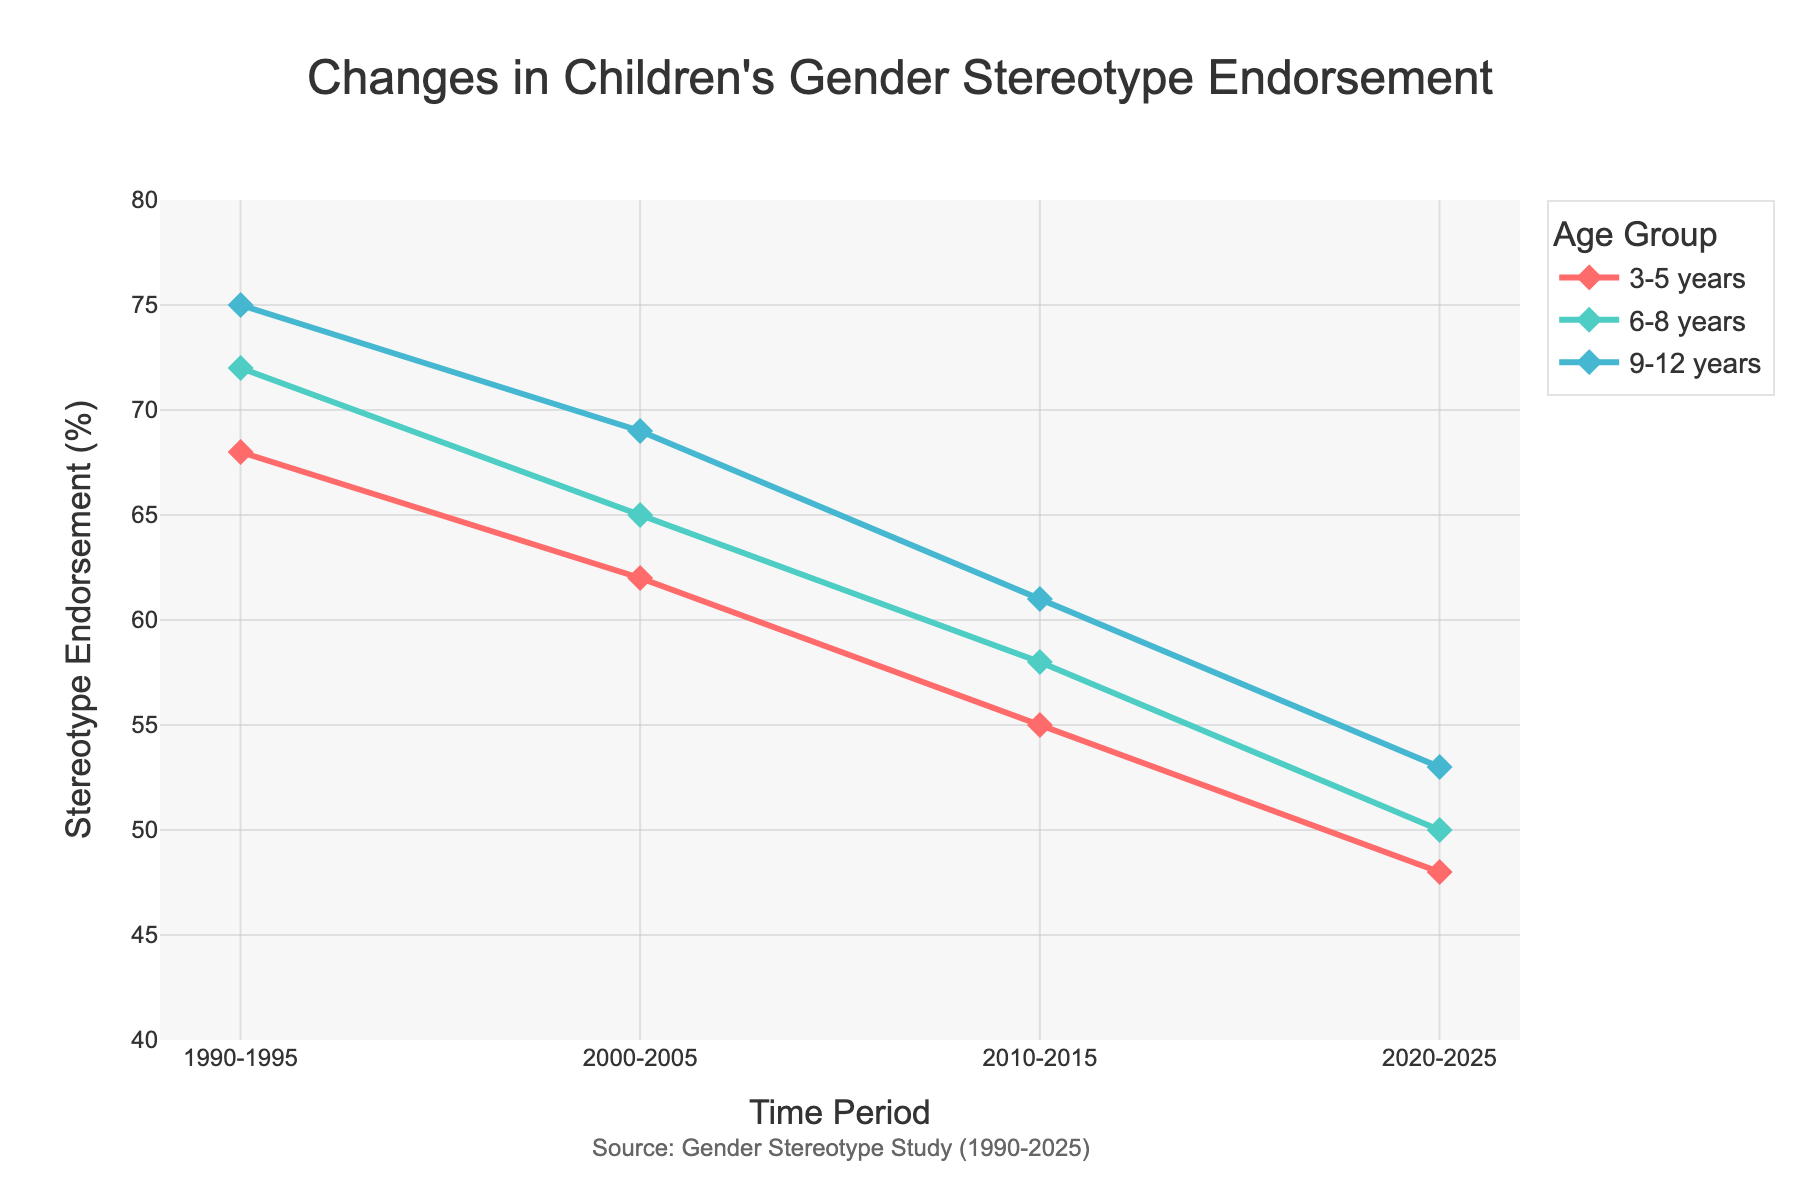What is the trend in gender stereotype endorsement for the 3-5 years age group over the past three decades? In the provided figure, the trend In the 3-5 years age group shows a steady decrease in gender stereotype endorsement over time. Initially starting at 68% in 1990-1995, it drops to 48% by 2020-2025.
Answer: Steady decrease Which age group showed the highest endorsement of gender stereotypes in the 2020-2025 period? The figure reveals that in the 2020-2025 period, the 9-12 years age group has the highest gender stereotype endorsement at 53%, compared to 50% for 6-8 years and 48% for 3-5 years.
Answer: 9-12 years When comparing boys and girls in the 9-12 years age group, which group showed a larger decline in endorsement of gender stereotypes from 1990-1995 to 2020-2025? The figure shows that boys in the 9-12 years age group declined from 78% to 58% (a 20% drop), whereas girls declined from 72% to 48% (a 24% drop). Thus, girls exhibited a larger decline.
Answer: Girls For the 6-8 years age group across all the years, what is the average percentage of gender stereotype endorsement? First, compute the average for each period: (72 + 65 + 58 + 50)/4. The average would sum to (72 + 65 + 58 + 50) = 245. Dividing by 4 gives 61.25%.
Answer: 61.25% Comparing career-related and toy preference stereotypes in the 2010-2015 period, which type had a higher endorsement rate? Looking at the respective values in the figure for 2010-2015, career-related stereotypes had 67%, while toy preference stereotypes had 69%. Thus, toy preference stereotypes had a higher endorsement rate.
Answer: Toy preference stereotypes By how much did the endorsement of behavior-related stereotypes decrease from 1990-1995 to 2020-2025? In the figure, the behavior-related stereotypes endorsement decreases from 72% (1990-1995) to 51% (2020-2025). The change is calculated as 72% - 51% = 21%.
Answer: 21% What is the largest drop in stereotype endorsement observed for any stereotype type between 2000-2005 and 2020-2025? Calculate the drop for each stereotype, appearances: 70%-55%=15%; career-related: 74%-59%=15%; behavior-related: 66%-51%=15%; toy preference: 76%-61%=15%; academic: 64%-49%=15%. Each one shows the largest drop of 15%.
Answer: 15% 